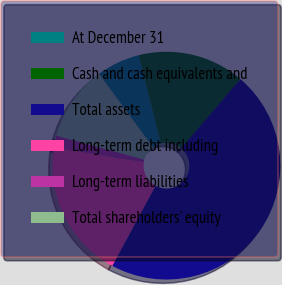<chart> <loc_0><loc_0><loc_500><loc_500><pie_chart><fcel>At December 31<fcel>Cash and cash equivalents and<fcel>Total assets<fcel>Long-term debt including<fcel>Long-term liabilities<fcel>Total shareholders' equity<nl><fcel>6.18%<fcel>15.17%<fcel>46.62%<fcel>19.66%<fcel>1.69%<fcel>10.68%<nl></chart> 